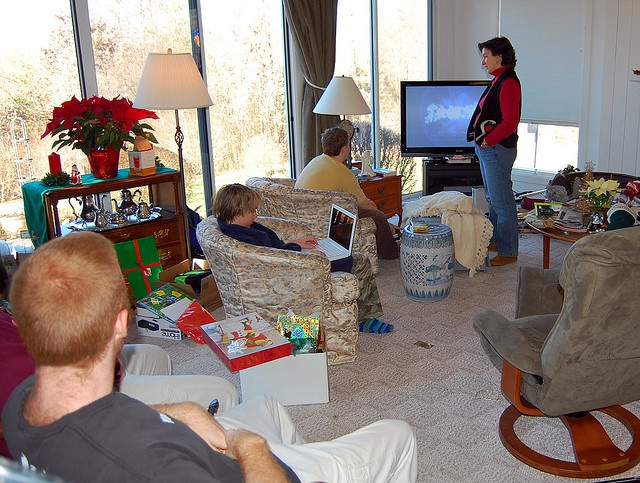Describe the objects in this image and their specific colors. I can see people in white, gray, brown, lightgray, and tan tones, chair in white, gray, maroon, and black tones, couch in white, darkgray, and gray tones, chair in white, darkgray, and gray tones, and people in white, black, maroon, navy, and darkblue tones in this image. 